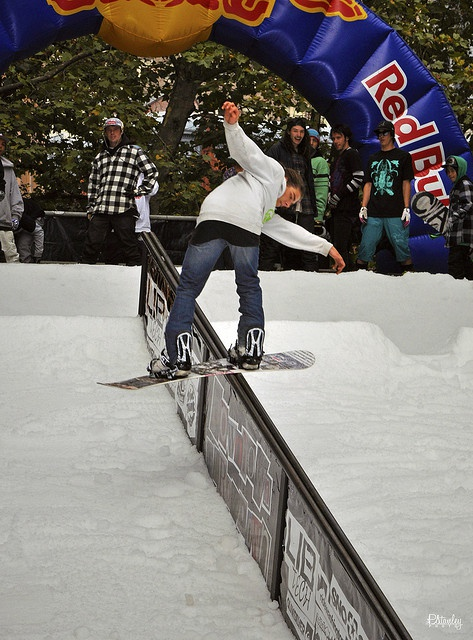Describe the objects in this image and their specific colors. I can see people in navy, black, lightgray, darkgray, and gray tones, people in navy, black, gray, lightgray, and darkgray tones, people in navy, black, teal, maroon, and darkblue tones, people in navy, black, maroon, and gray tones, and snowboard in navy, darkgray, gray, black, and lightgray tones in this image. 